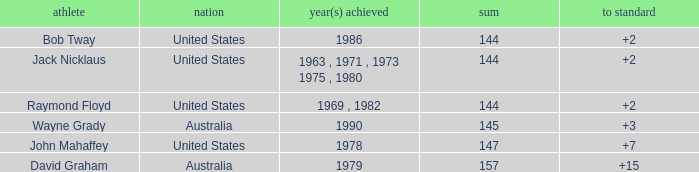What was the average round score of the player who won in 1978? 147.0. 